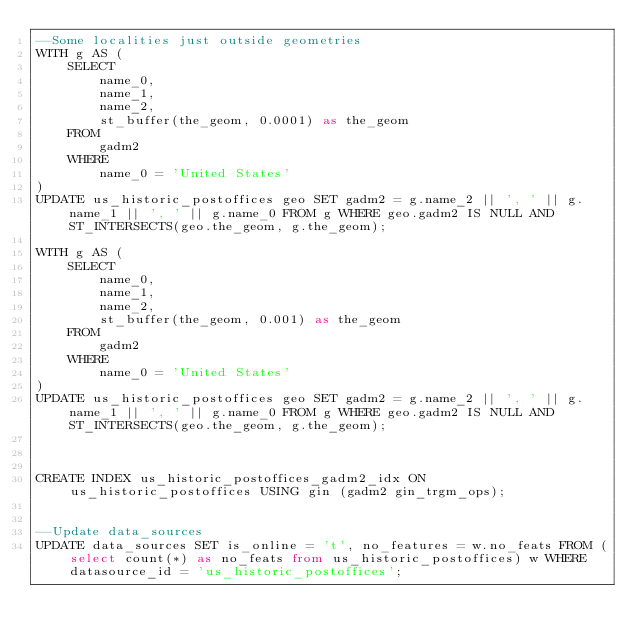<code> <loc_0><loc_0><loc_500><loc_500><_SQL_>--Some localities just outside geometries
WITH g AS (
    SELECT
        name_0,
        name_1,
        name_2,
        st_buffer(the_geom, 0.0001) as the_geom
    FROM
        gadm2
    WHERE
        name_0 = 'United States'
)
UPDATE us_historic_postoffices geo SET gadm2 = g.name_2 || ', ' || g.name_1 || ', ' || g.name_0 FROM g WHERE geo.gadm2 IS NULL AND  ST_INTERSECTS(geo.the_geom, g.the_geom);

WITH g AS (
    SELECT
        name_0,
        name_1,
        name_2,
        st_buffer(the_geom, 0.001) as the_geom
    FROM
        gadm2
    WHERE
        name_0 = 'United States'
)
UPDATE us_historic_postoffices geo SET gadm2 = g.name_2 || ', ' || g.name_1 || ', ' || g.name_0 FROM g WHERE geo.gadm2 IS NULL AND  ST_INTERSECTS(geo.the_geom, g.the_geom);



CREATE INDEX us_historic_postoffices_gadm2_idx ON us_historic_postoffices USING gin (gadm2 gin_trgm_ops);


--Update data_sources
UPDATE data_sources SET is_online = 't', no_features = w.no_feats FROM (select count(*) as no_feats from us_historic_postoffices) w WHERE datasource_id = 'us_historic_postoffices';
</code> 